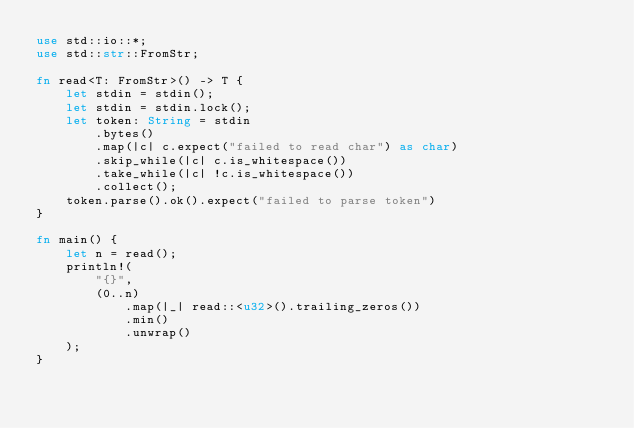Convert code to text. <code><loc_0><loc_0><loc_500><loc_500><_Rust_>use std::io::*;
use std::str::FromStr;

fn read<T: FromStr>() -> T {
    let stdin = stdin();
    let stdin = stdin.lock();
    let token: String = stdin
        .bytes()
        .map(|c| c.expect("failed to read char") as char)
        .skip_while(|c| c.is_whitespace())
        .take_while(|c| !c.is_whitespace())
        .collect();
    token.parse().ok().expect("failed to parse token")
}

fn main() {
    let n = read();
    println!(
        "{}",
        (0..n)
            .map(|_| read::<u32>().trailing_zeros())
            .min()
            .unwrap()
    );
}</code> 